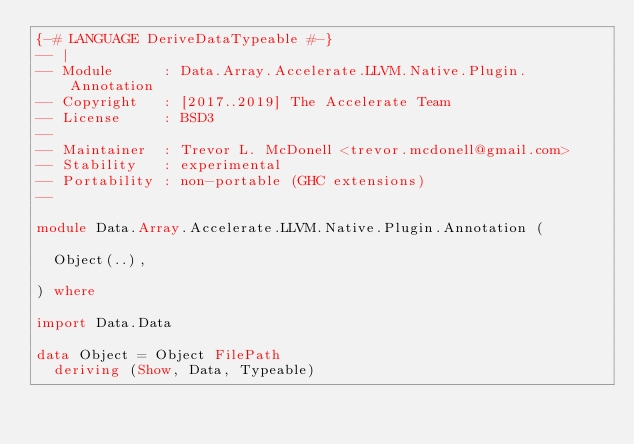Convert code to text. <code><loc_0><loc_0><loc_500><loc_500><_Haskell_>{-# LANGUAGE DeriveDataTypeable #-}
-- |
-- Module      : Data.Array.Accelerate.LLVM.Native.Plugin.Annotation
-- Copyright   : [2017..2019] The Accelerate Team
-- License     : BSD3
--
-- Maintainer  : Trevor L. McDonell <trevor.mcdonell@gmail.com>
-- Stability   : experimental
-- Portability : non-portable (GHC extensions)
--

module Data.Array.Accelerate.LLVM.Native.Plugin.Annotation (

  Object(..),

) where

import Data.Data

data Object = Object FilePath
  deriving (Show, Data, Typeable)

</code> 